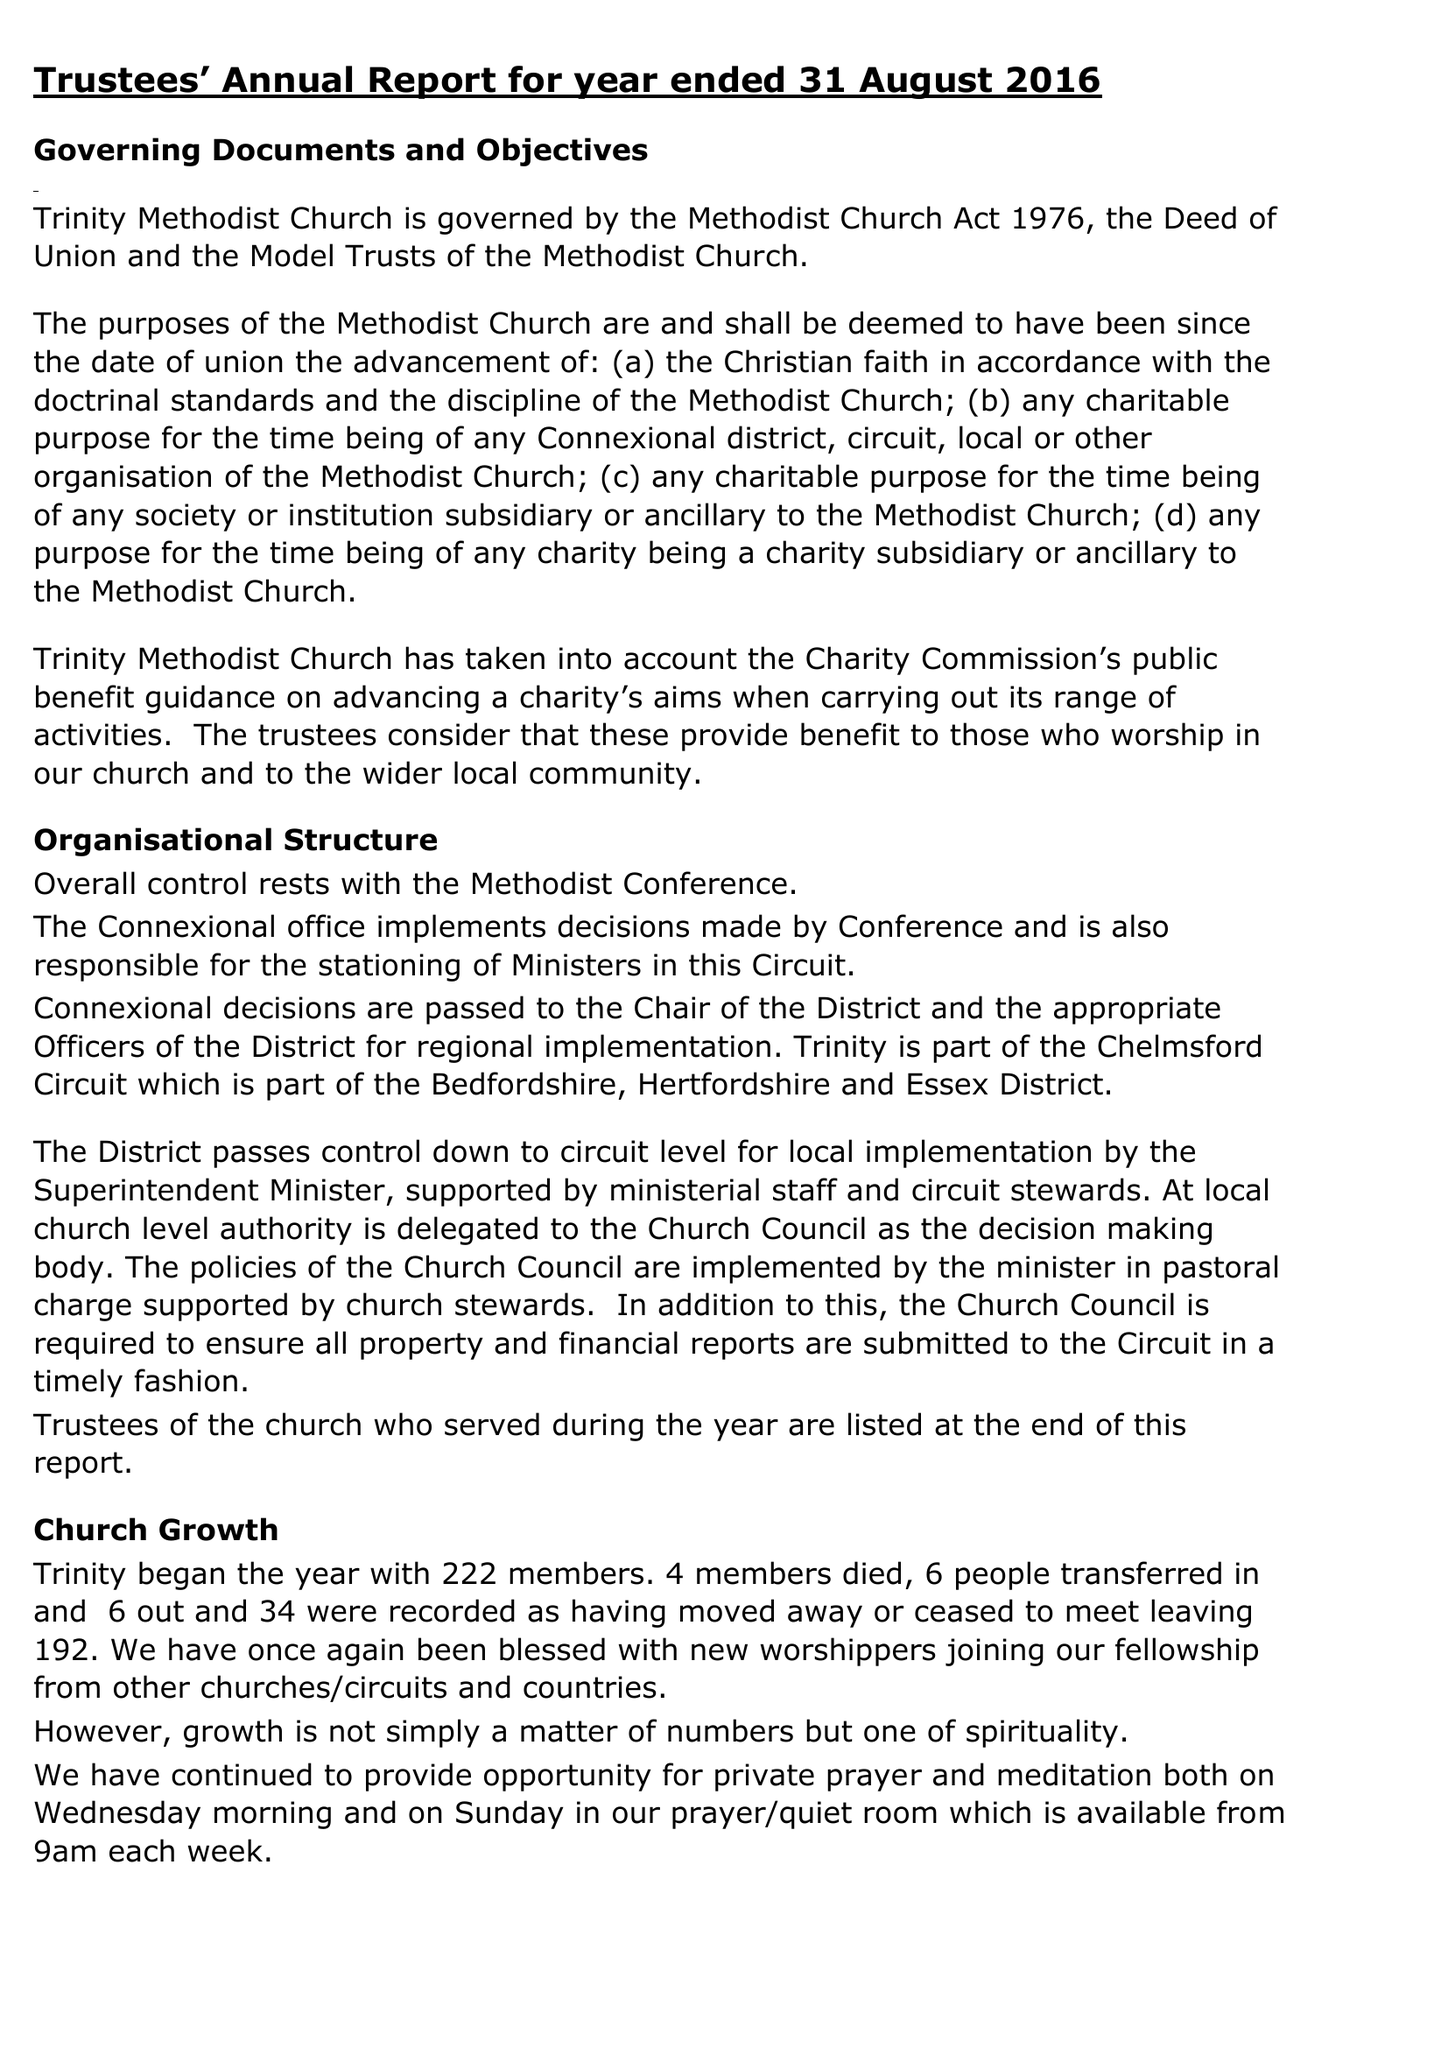What is the value for the report_date?
Answer the question using a single word or phrase. 2016-08-31 